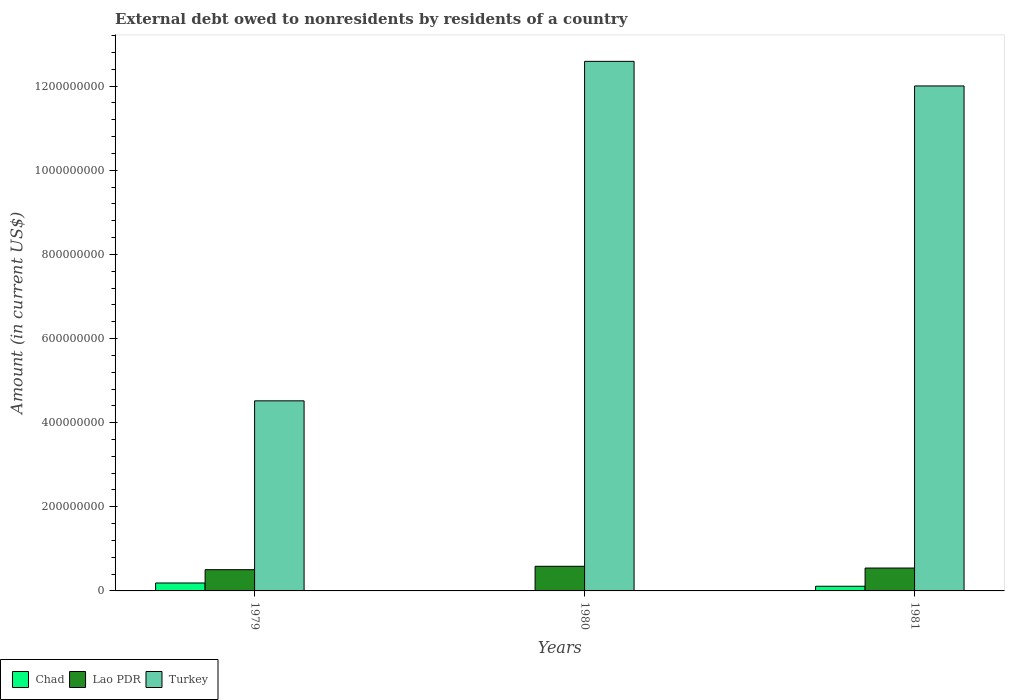How many different coloured bars are there?
Give a very brief answer. 3. Are the number of bars per tick equal to the number of legend labels?
Ensure brevity in your answer.  No. How many bars are there on the 2nd tick from the left?
Your answer should be compact. 2. What is the label of the 1st group of bars from the left?
Ensure brevity in your answer.  1979. What is the external debt owed by residents in Lao PDR in 1980?
Offer a very short reply. 5.86e+07. Across all years, what is the maximum external debt owed by residents in Chad?
Your answer should be very brief. 1.89e+07. In which year was the external debt owed by residents in Turkey maximum?
Give a very brief answer. 1980. What is the total external debt owed by residents in Lao PDR in the graph?
Your answer should be very brief. 1.63e+08. What is the difference between the external debt owed by residents in Lao PDR in 1979 and that in 1981?
Ensure brevity in your answer.  -3.88e+06. What is the difference between the external debt owed by residents in Chad in 1981 and the external debt owed by residents in Turkey in 1979?
Provide a short and direct response. -4.41e+08. What is the average external debt owed by residents in Turkey per year?
Your answer should be very brief. 9.70e+08. In the year 1979, what is the difference between the external debt owed by residents in Turkey and external debt owed by residents in Lao PDR?
Your response must be concise. 4.01e+08. What is the ratio of the external debt owed by residents in Lao PDR in 1980 to that in 1981?
Your answer should be compact. 1.08. Is the difference between the external debt owed by residents in Turkey in 1979 and 1980 greater than the difference between the external debt owed by residents in Lao PDR in 1979 and 1980?
Provide a short and direct response. No. What is the difference between the highest and the second highest external debt owed by residents in Turkey?
Keep it short and to the point. 5.85e+07. What is the difference between the highest and the lowest external debt owed by residents in Chad?
Give a very brief answer. 1.89e+07. Is it the case that in every year, the sum of the external debt owed by residents in Chad and external debt owed by residents in Lao PDR is greater than the external debt owed by residents in Turkey?
Offer a very short reply. No. How many bars are there?
Your response must be concise. 8. Are all the bars in the graph horizontal?
Your answer should be compact. No. What is the difference between two consecutive major ticks on the Y-axis?
Provide a succinct answer. 2.00e+08. Are the values on the major ticks of Y-axis written in scientific E-notation?
Provide a short and direct response. No. Where does the legend appear in the graph?
Ensure brevity in your answer.  Bottom left. What is the title of the graph?
Provide a short and direct response. External debt owed to nonresidents by residents of a country. Does "Senegal" appear as one of the legend labels in the graph?
Offer a very short reply. No. What is the label or title of the Y-axis?
Offer a terse response. Amount (in current US$). What is the Amount (in current US$) in Chad in 1979?
Make the answer very short. 1.89e+07. What is the Amount (in current US$) of Lao PDR in 1979?
Your answer should be compact. 5.05e+07. What is the Amount (in current US$) in Turkey in 1979?
Your answer should be compact. 4.52e+08. What is the Amount (in current US$) of Chad in 1980?
Your response must be concise. 0. What is the Amount (in current US$) of Lao PDR in 1980?
Provide a succinct answer. 5.86e+07. What is the Amount (in current US$) of Turkey in 1980?
Provide a succinct answer. 1.26e+09. What is the Amount (in current US$) of Chad in 1981?
Your response must be concise. 1.11e+07. What is the Amount (in current US$) in Lao PDR in 1981?
Keep it short and to the point. 5.44e+07. What is the Amount (in current US$) of Turkey in 1981?
Your answer should be very brief. 1.20e+09. Across all years, what is the maximum Amount (in current US$) of Chad?
Offer a very short reply. 1.89e+07. Across all years, what is the maximum Amount (in current US$) in Lao PDR?
Give a very brief answer. 5.86e+07. Across all years, what is the maximum Amount (in current US$) in Turkey?
Your answer should be compact. 1.26e+09. Across all years, what is the minimum Amount (in current US$) of Lao PDR?
Offer a very short reply. 5.05e+07. Across all years, what is the minimum Amount (in current US$) in Turkey?
Give a very brief answer. 4.52e+08. What is the total Amount (in current US$) in Chad in the graph?
Offer a very short reply. 3.00e+07. What is the total Amount (in current US$) of Lao PDR in the graph?
Make the answer very short. 1.63e+08. What is the total Amount (in current US$) in Turkey in the graph?
Your answer should be compact. 2.91e+09. What is the difference between the Amount (in current US$) of Lao PDR in 1979 and that in 1980?
Your answer should be compact. -8.04e+06. What is the difference between the Amount (in current US$) in Turkey in 1979 and that in 1980?
Ensure brevity in your answer.  -8.07e+08. What is the difference between the Amount (in current US$) in Chad in 1979 and that in 1981?
Make the answer very short. 7.76e+06. What is the difference between the Amount (in current US$) in Lao PDR in 1979 and that in 1981?
Ensure brevity in your answer.  -3.88e+06. What is the difference between the Amount (in current US$) in Turkey in 1979 and that in 1981?
Your response must be concise. -7.49e+08. What is the difference between the Amount (in current US$) in Lao PDR in 1980 and that in 1981?
Offer a terse response. 4.16e+06. What is the difference between the Amount (in current US$) of Turkey in 1980 and that in 1981?
Your answer should be compact. 5.85e+07. What is the difference between the Amount (in current US$) in Chad in 1979 and the Amount (in current US$) in Lao PDR in 1980?
Offer a very short reply. -3.97e+07. What is the difference between the Amount (in current US$) in Chad in 1979 and the Amount (in current US$) in Turkey in 1980?
Keep it short and to the point. -1.24e+09. What is the difference between the Amount (in current US$) of Lao PDR in 1979 and the Amount (in current US$) of Turkey in 1980?
Your answer should be compact. -1.21e+09. What is the difference between the Amount (in current US$) in Chad in 1979 and the Amount (in current US$) in Lao PDR in 1981?
Make the answer very short. -3.55e+07. What is the difference between the Amount (in current US$) of Chad in 1979 and the Amount (in current US$) of Turkey in 1981?
Your answer should be very brief. -1.18e+09. What is the difference between the Amount (in current US$) of Lao PDR in 1979 and the Amount (in current US$) of Turkey in 1981?
Provide a succinct answer. -1.15e+09. What is the difference between the Amount (in current US$) of Lao PDR in 1980 and the Amount (in current US$) of Turkey in 1981?
Keep it short and to the point. -1.14e+09. What is the average Amount (in current US$) of Chad per year?
Ensure brevity in your answer.  9.99e+06. What is the average Amount (in current US$) of Lao PDR per year?
Provide a succinct answer. 5.45e+07. What is the average Amount (in current US$) of Turkey per year?
Make the answer very short. 9.70e+08. In the year 1979, what is the difference between the Amount (in current US$) of Chad and Amount (in current US$) of Lao PDR?
Offer a very short reply. -3.17e+07. In the year 1979, what is the difference between the Amount (in current US$) in Chad and Amount (in current US$) in Turkey?
Keep it short and to the point. -4.33e+08. In the year 1979, what is the difference between the Amount (in current US$) in Lao PDR and Amount (in current US$) in Turkey?
Make the answer very short. -4.01e+08. In the year 1980, what is the difference between the Amount (in current US$) in Lao PDR and Amount (in current US$) in Turkey?
Your response must be concise. -1.20e+09. In the year 1981, what is the difference between the Amount (in current US$) of Chad and Amount (in current US$) of Lao PDR?
Your answer should be compact. -4.33e+07. In the year 1981, what is the difference between the Amount (in current US$) in Chad and Amount (in current US$) in Turkey?
Give a very brief answer. -1.19e+09. In the year 1981, what is the difference between the Amount (in current US$) in Lao PDR and Amount (in current US$) in Turkey?
Your answer should be compact. -1.15e+09. What is the ratio of the Amount (in current US$) of Lao PDR in 1979 to that in 1980?
Your response must be concise. 0.86. What is the ratio of the Amount (in current US$) of Turkey in 1979 to that in 1980?
Provide a short and direct response. 0.36. What is the ratio of the Amount (in current US$) of Chad in 1979 to that in 1981?
Your answer should be compact. 1.7. What is the ratio of the Amount (in current US$) in Lao PDR in 1979 to that in 1981?
Ensure brevity in your answer.  0.93. What is the ratio of the Amount (in current US$) of Turkey in 1979 to that in 1981?
Ensure brevity in your answer.  0.38. What is the ratio of the Amount (in current US$) of Lao PDR in 1980 to that in 1981?
Give a very brief answer. 1.08. What is the ratio of the Amount (in current US$) of Turkey in 1980 to that in 1981?
Give a very brief answer. 1.05. What is the difference between the highest and the second highest Amount (in current US$) in Lao PDR?
Offer a terse response. 4.16e+06. What is the difference between the highest and the second highest Amount (in current US$) of Turkey?
Your answer should be compact. 5.85e+07. What is the difference between the highest and the lowest Amount (in current US$) in Chad?
Your answer should be compact. 1.89e+07. What is the difference between the highest and the lowest Amount (in current US$) of Lao PDR?
Keep it short and to the point. 8.04e+06. What is the difference between the highest and the lowest Amount (in current US$) of Turkey?
Provide a short and direct response. 8.07e+08. 